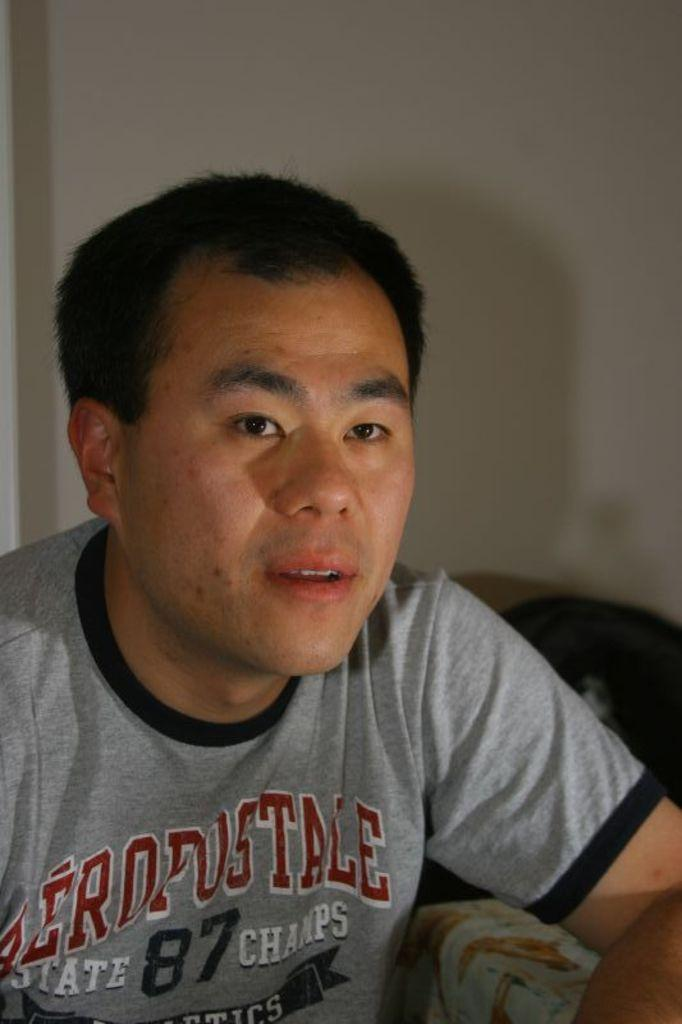Who or what is the main subject in the image? There is a person in the image. What is behind the person in the image? The person is in front of a wall. What is the person wearing in the image? The person is wearing clothes. What type of rice is being served in the image? There is no rice present in the image; it features a person in front of a wall. How many trucks can be seen in the image? There are no trucks present in the image. 